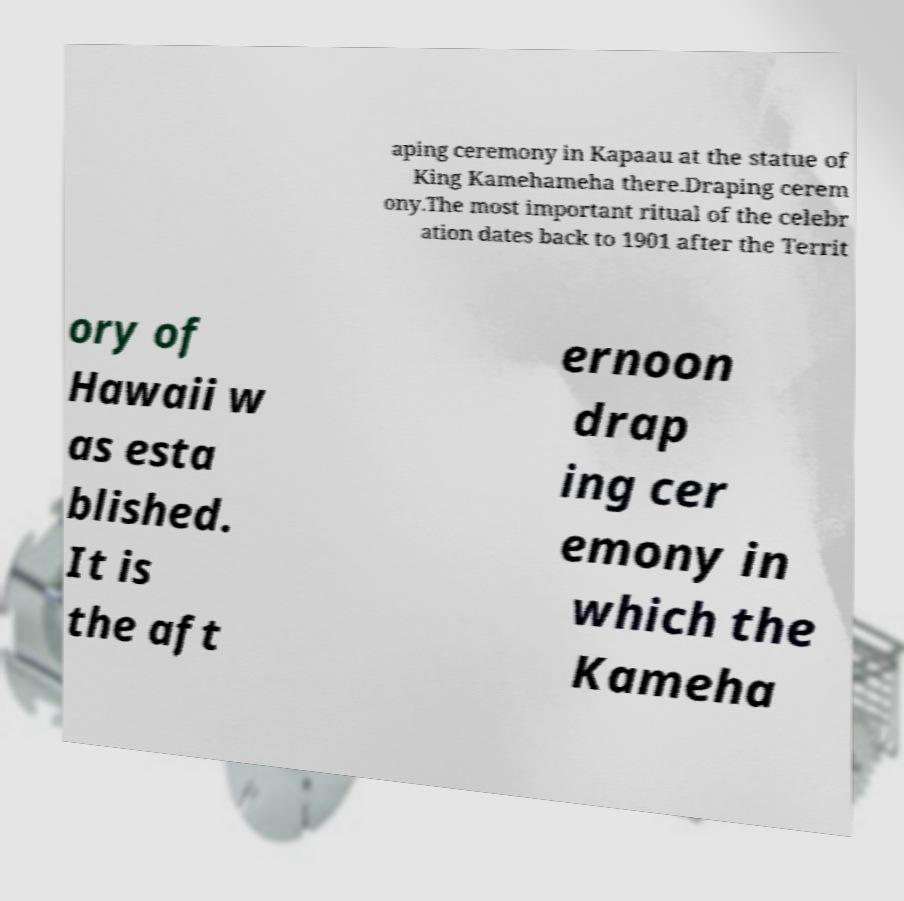Can you read and provide the text displayed in the image?This photo seems to have some interesting text. Can you extract and type it out for me? aping ceremony in Kapaau at the statue of King Kamehameha there.Draping cerem ony.The most important ritual of the celebr ation dates back to 1901 after the Territ ory of Hawaii w as esta blished. It is the aft ernoon drap ing cer emony in which the Kameha 